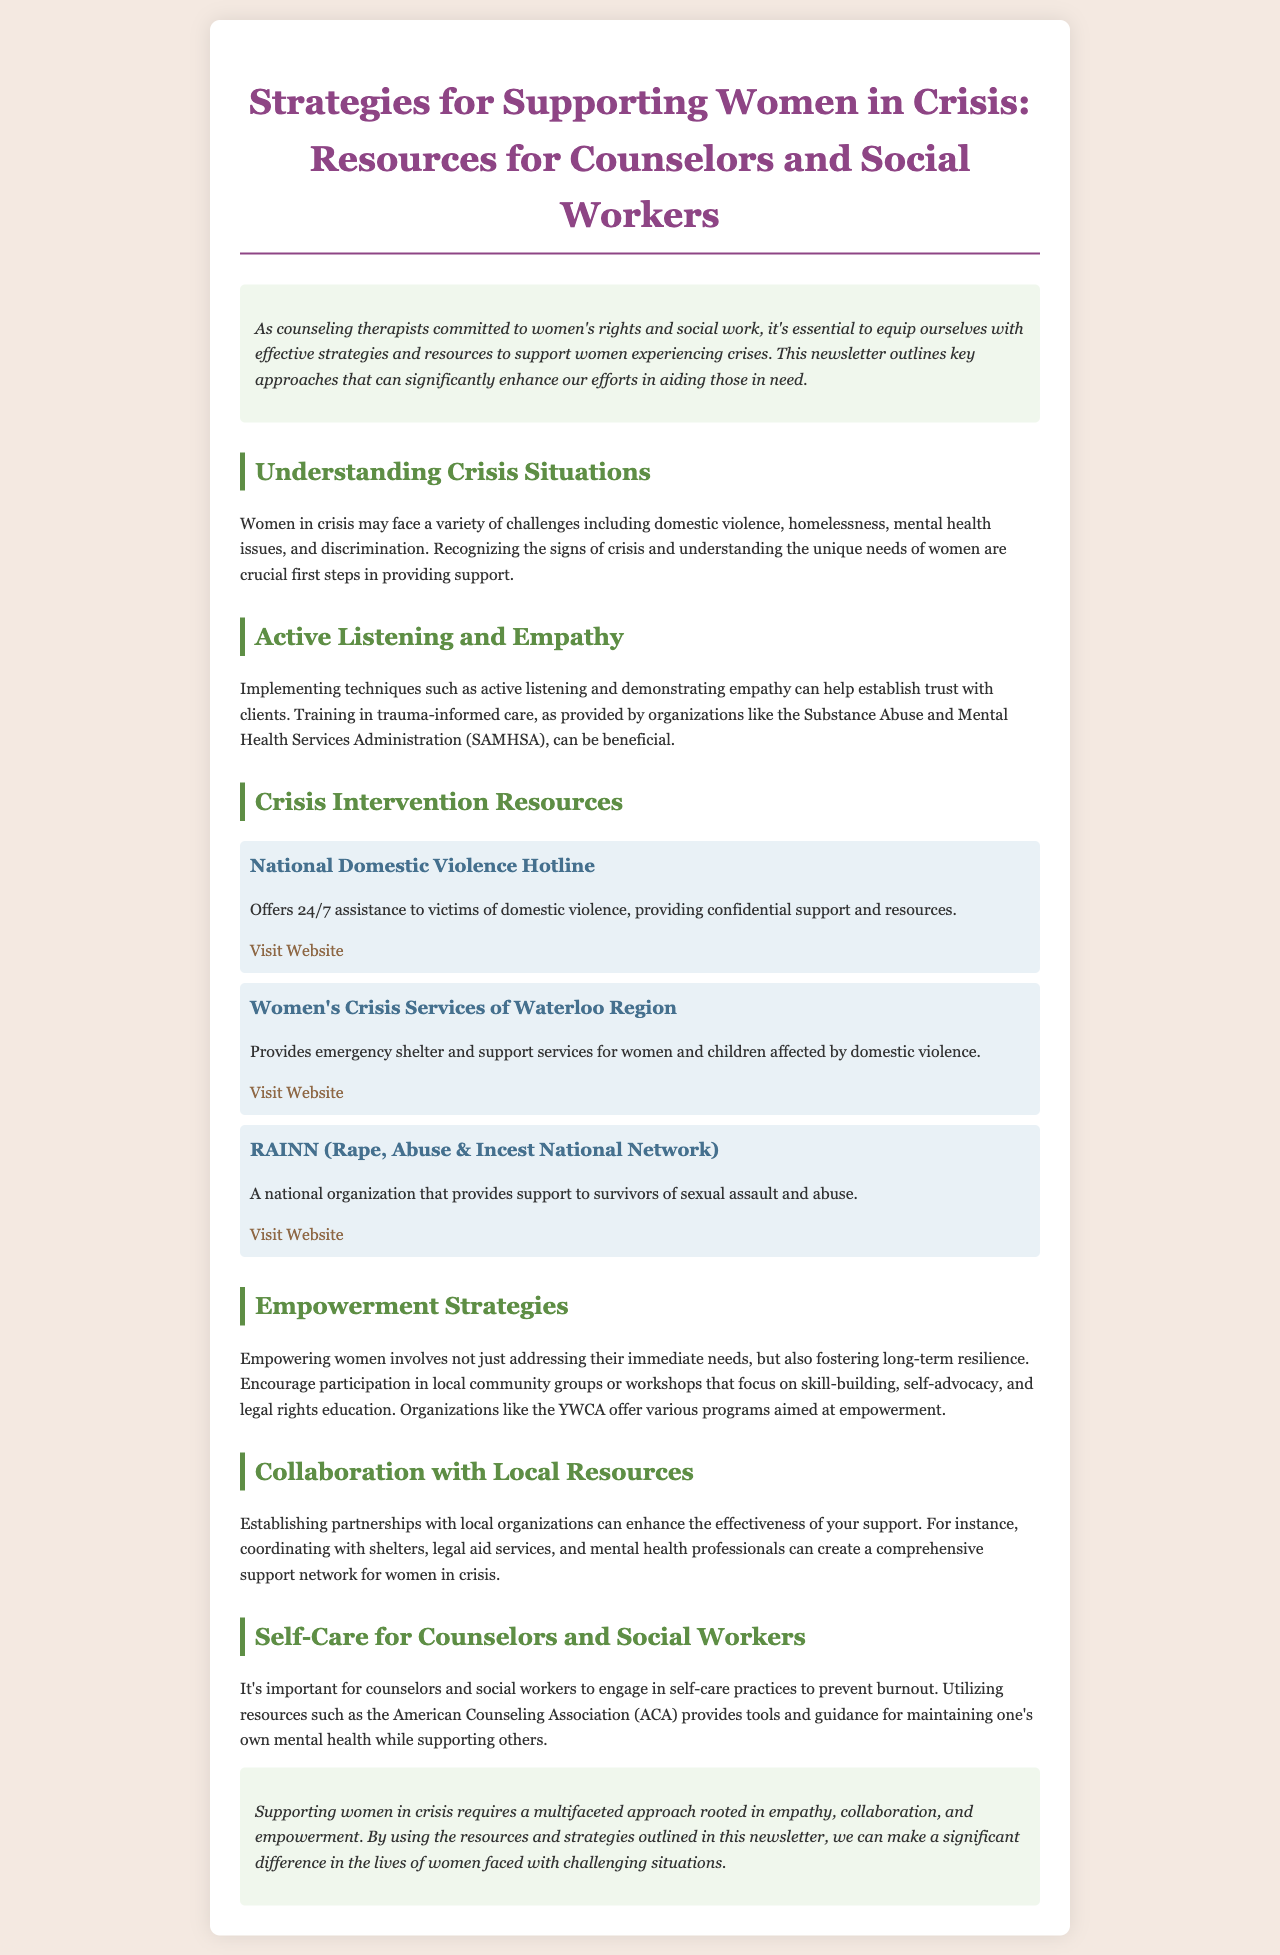What is the title of the newsletter? The title is provided at the top of the document, indicating the main focus of the content.
Answer: Strategies for Supporting Women in Crisis: Resources for Counselors and Social Workers How many organizations are mentioned in the Crisis Intervention Resources section? The document lists three specific organizations that offer crisis intervention resources.
Answer: 3 What is one technique mentioned for establishing trust with clients? The newsletter states that implementing certain techniques such as active listening can help build trust.
Answer: Active listening Which organization provides emergency shelter and support services for women and children? The document specifies a particular organization that offers these services, enhancing the understanding of available resources.
Answer: Women's Crisis Services of Waterloo Region What is one empowerment strategy suggested in the document? The content suggests encouraging participation in community groups or workshops as a method for empowering women.
Answer: Community groups What is highlighted as essential for counselors and social workers to prevent burnout? The newsletter emphasizes the importance of engaging in self-care practices to maintain mental health.
Answer: Self-care practices What color is used for the heading of the introduction section? The color scheme used in the document is specified for various parts, including the heading of the introduction.
Answer: Green What are counselors encouraged to establish with local organizations? The text discusses the importance of collaboration with local entities to enhance support for women in crisis.
Answer: Partnerships 